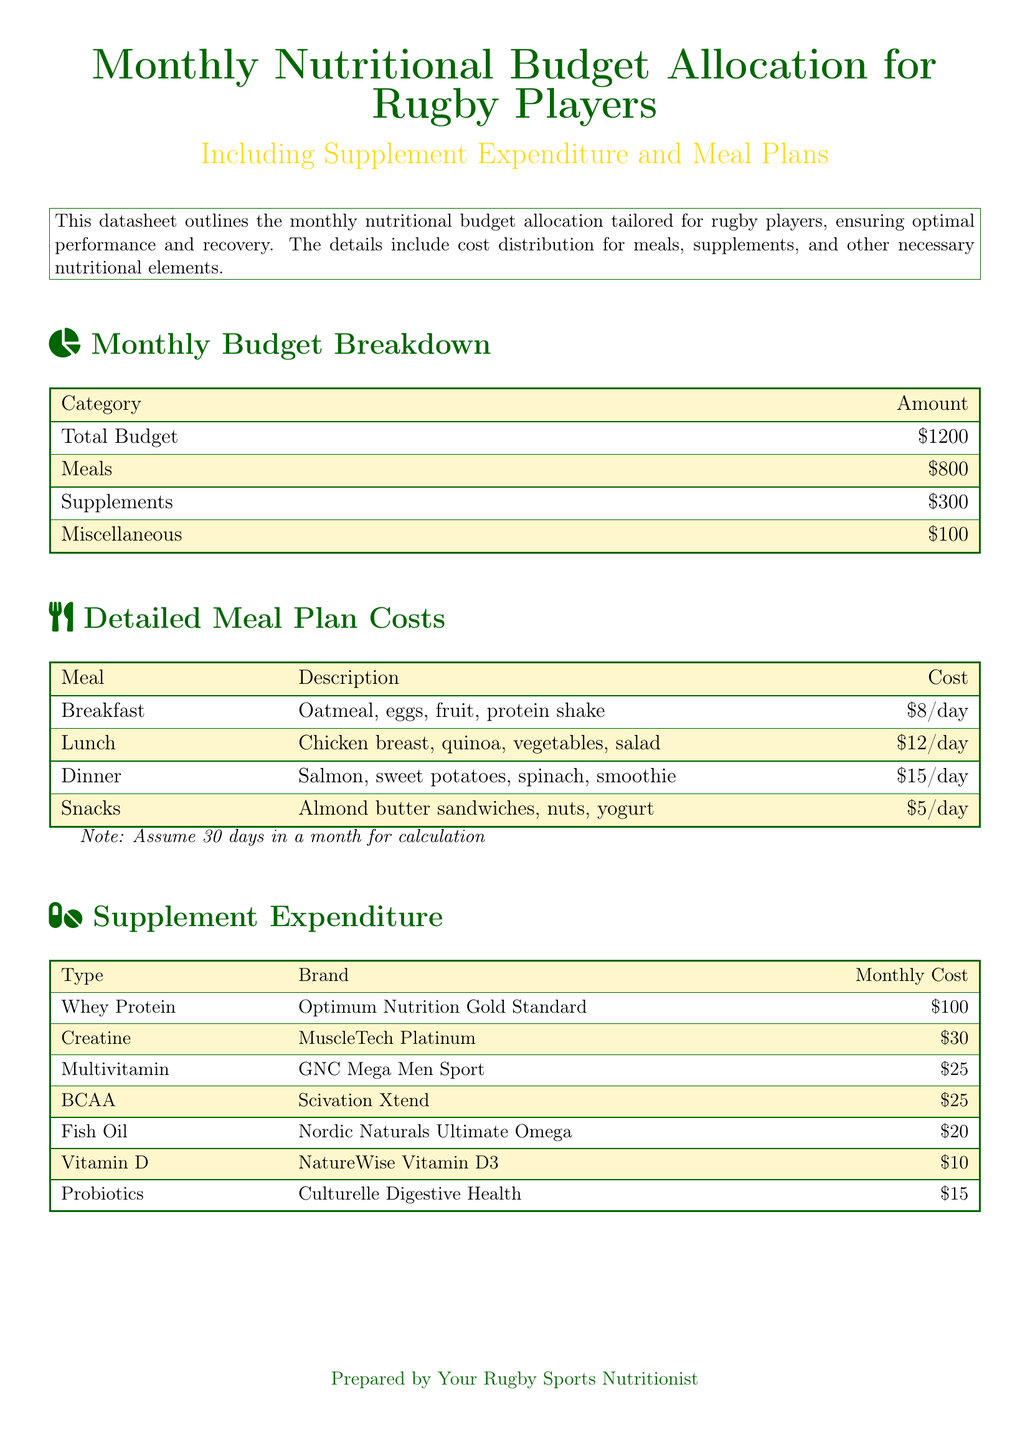What is the total budget allocated for nutrition? The total budget is stated in the Monthly Budget Breakdown section of the datasheet.
Answer: $1200 How much is allocated for meals? The meals allocation can be found in the Monthly Budget Breakdown table.
Answer: $800 What is the daily cost of breakfast? The daily cost of breakfast is specified in the Detailed Meal Plan Costs section.
Answer: $8/day How much does whey protein cost per month? The monthly cost of whey protein is listed in the Supplement Expenditure table.
Answer: $100 What type of supplement is Scivation Xtend? The type of supplement for Scivation Xtend is mentioned in the Supplement Expenditure section.
Answer: BCAA What is the total cost for snacks for a month? The total cost can be calculated by multiplying the daily cost of snacks by the number of days in a month.
Answer: $150 Which meal has the highest daily cost? The meal with the highest daily cost can be determined by comparing costs in the Detailed Meal Plan Costs section.
Answer: Dinner How much is allocated for supplements? The amount for supplements can be found in the Monthly Budget Breakdown section.
Answer: $300 What brand is associated with multivitamins? The brand for multivitamins is provided in the Supplement Expenditure table.
Answer: GNC Mega Men Sport 